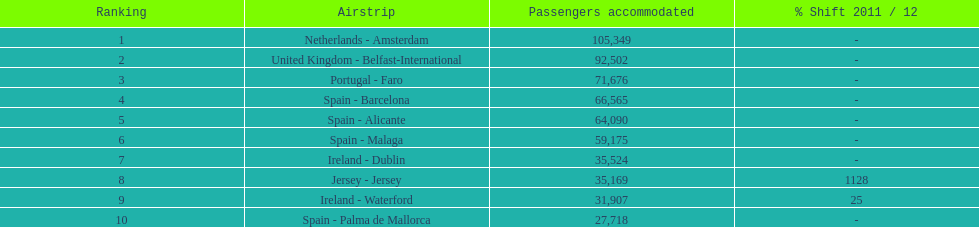Looking at the top 10 busiest routes to and from london southend airport what is the average number of passengers handled? 58,967.5. 